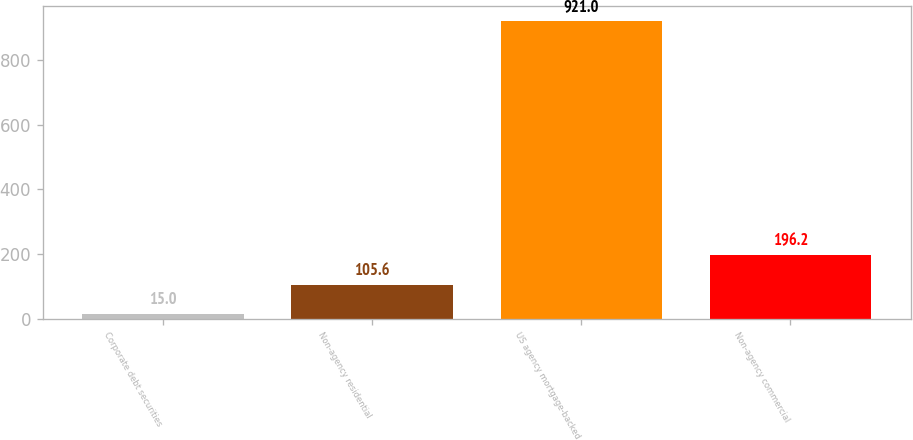<chart> <loc_0><loc_0><loc_500><loc_500><bar_chart><fcel>Corporate debt securities<fcel>Non-agency residential<fcel>US agency mortgage-backed<fcel>Non-agency commercial<nl><fcel>15<fcel>105.6<fcel>921<fcel>196.2<nl></chart> 